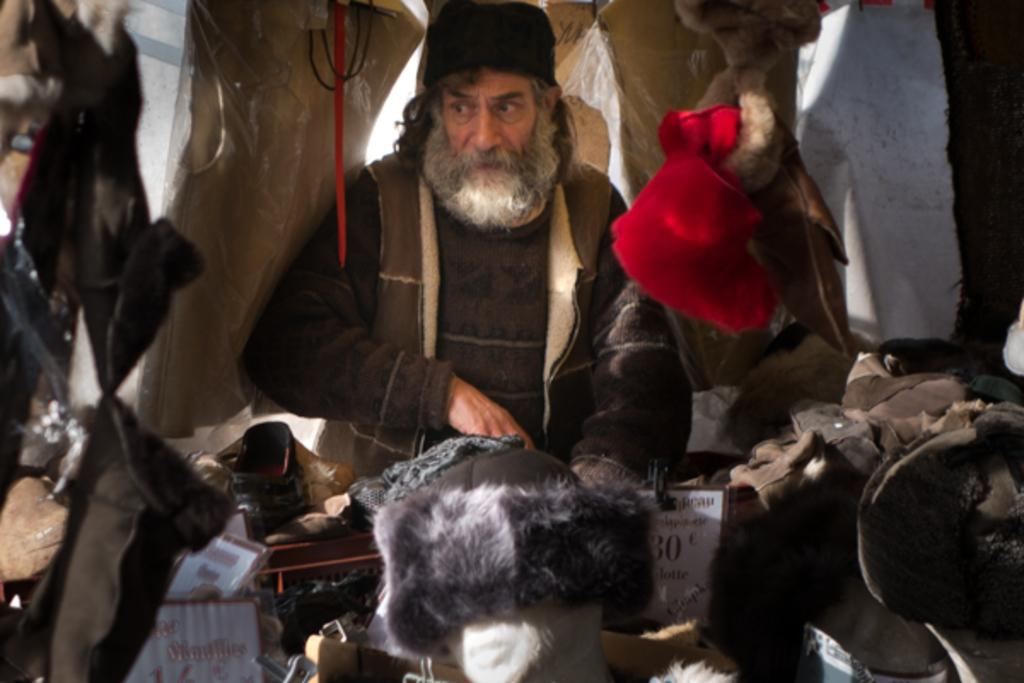What is the main subject of the image? There is a person standing in the image. What is in front of the person? There are many clothes in front of the person. Are there any clothes that are not on the ground? Yes, some clothes are hanging in the image. What type of toy can be seen in the hands of the person in the image? There is no toy visible in the image; the person is not holding anything. 